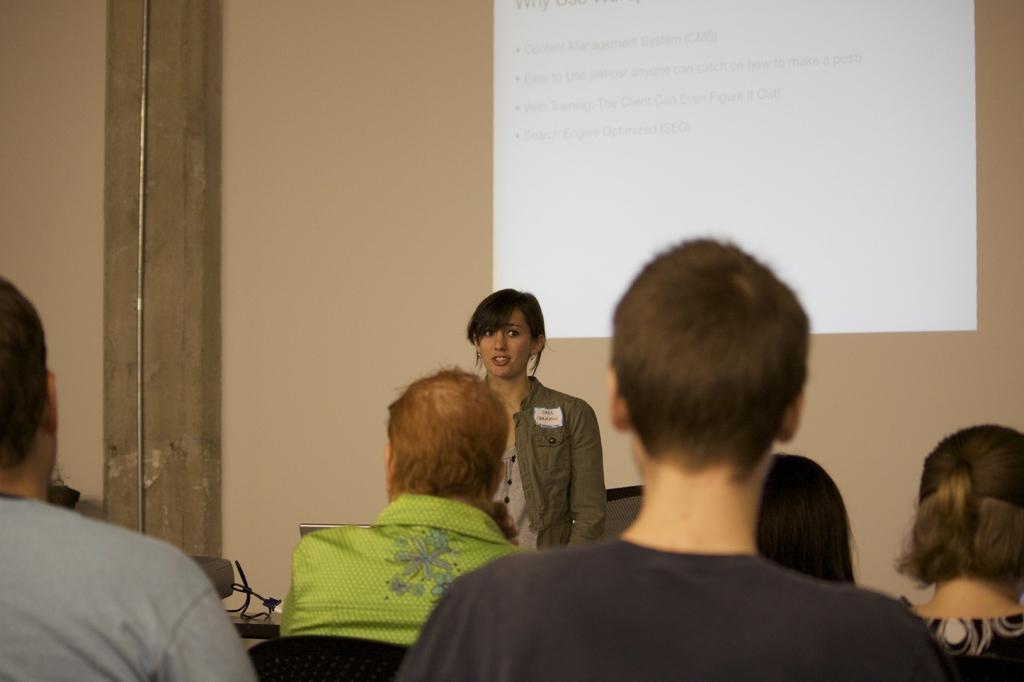Please provide a concise description of this image. In this image, we can see a group of people. Few are sitting. Here a person is standing and looking at the right side. Background we can see a well, screen, pipe and few wires. 